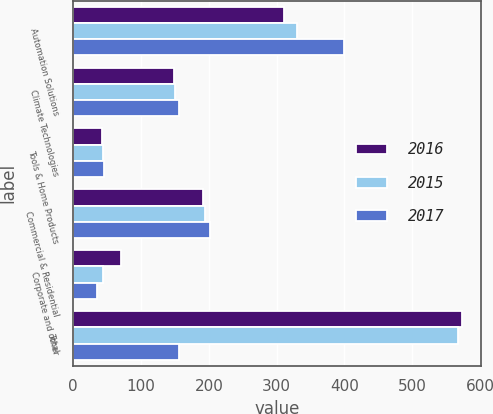<chart> <loc_0><loc_0><loc_500><loc_500><stacked_bar_chart><ecel><fcel>Automation Solutions<fcel>Climate Technologies<fcel>Tools & Home Products<fcel>Commercial & Residential<fcel>Corporate and other<fcel>Total<nl><fcel>2016<fcel>311<fcel>149<fcel>42<fcel>191<fcel>71<fcel>573<nl><fcel>2015<fcel>330<fcel>150<fcel>44<fcel>194<fcel>44<fcel>568<nl><fcel>2017<fcel>400<fcel>156<fcel>45<fcel>201<fcel>35<fcel>156<nl></chart> 